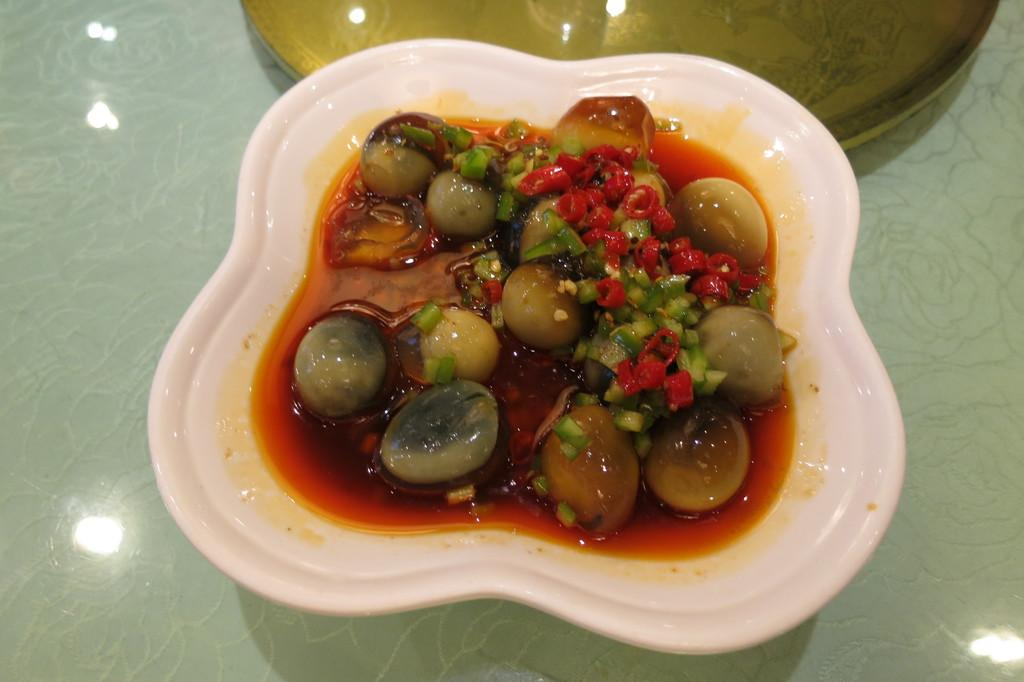What is present on the plate in the image? There is food in a plate in the image. How many fingers can be seen touching the food in the image? There are no fingers visible touching the food in the image. What is the monetary value of the food in the image? The provided facts do not mention any monetary value associated with the food in the image. 